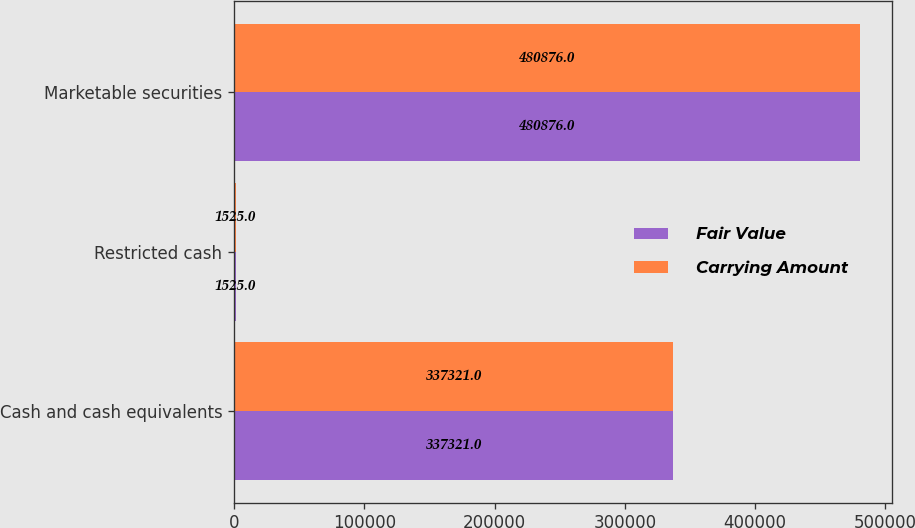Convert chart. <chart><loc_0><loc_0><loc_500><loc_500><stacked_bar_chart><ecel><fcel>Cash and cash equivalents<fcel>Restricted cash<fcel>Marketable securities<nl><fcel>Fair Value<fcel>337321<fcel>1525<fcel>480876<nl><fcel>Carrying Amount<fcel>337321<fcel>1525<fcel>480876<nl></chart> 